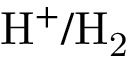Convert formula to latex. <formula><loc_0><loc_0><loc_500><loc_500>H ^ { + } / H _ { 2 }</formula> 